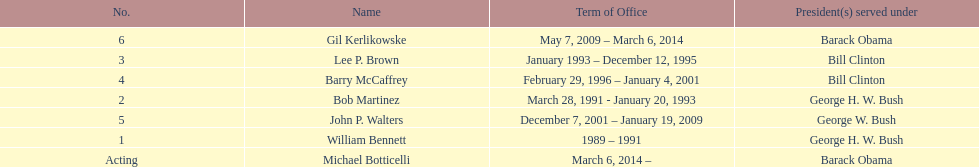What were the total number of years bob martinez served in office? 2. 